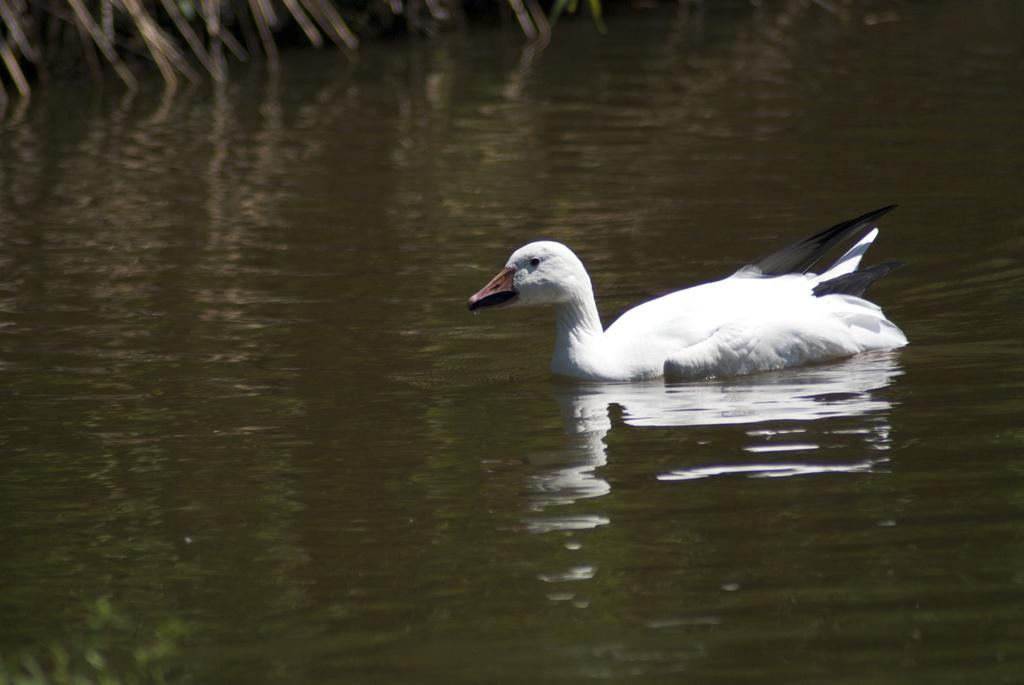What is visible in the image? There is water visible in the image. Are there any animals present in the image? Yes, there is a duck in the image. What is the name of the daughter in the image? There is no daughter present in the image. How many eggs can be seen in the image? There are no eggs visible in the image. 